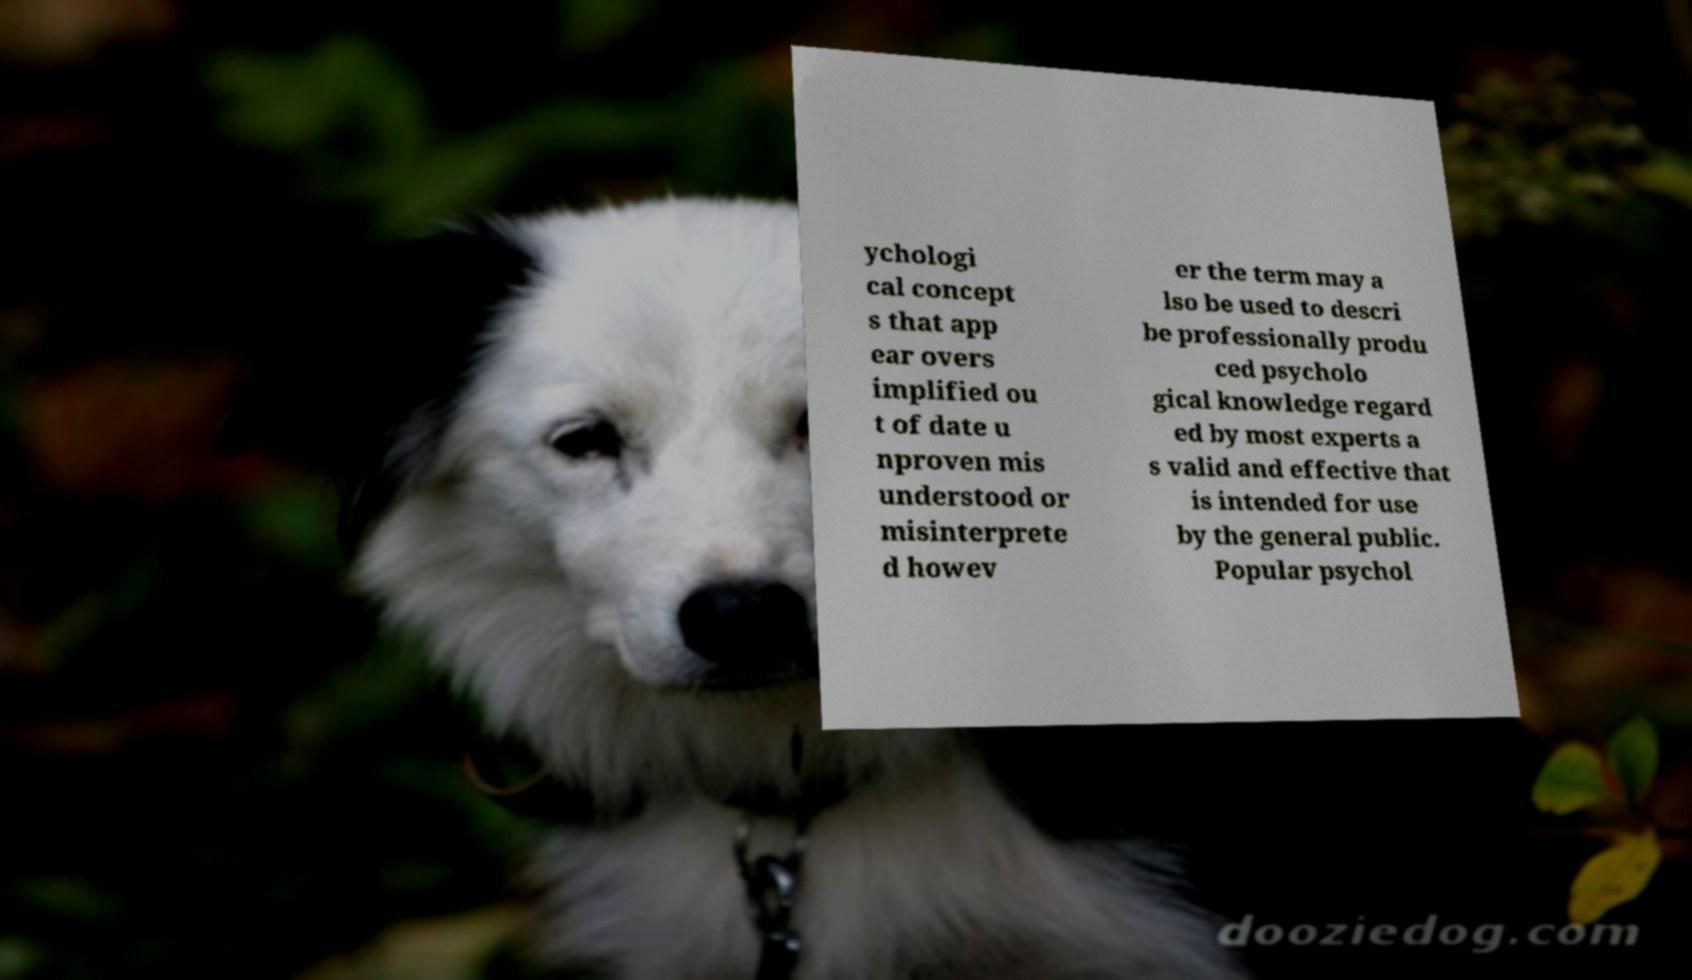There's text embedded in this image that I need extracted. Can you transcribe it verbatim? ychologi cal concept s that app ear overs implified ou t of date u nproven mis understood or misinterprete d howev er the term may a lso be used to descri be professionally produ ced psycholo gical knowledge regard ed by most experts a s valid and effective that is intended for use by the general public. Popular psychol 